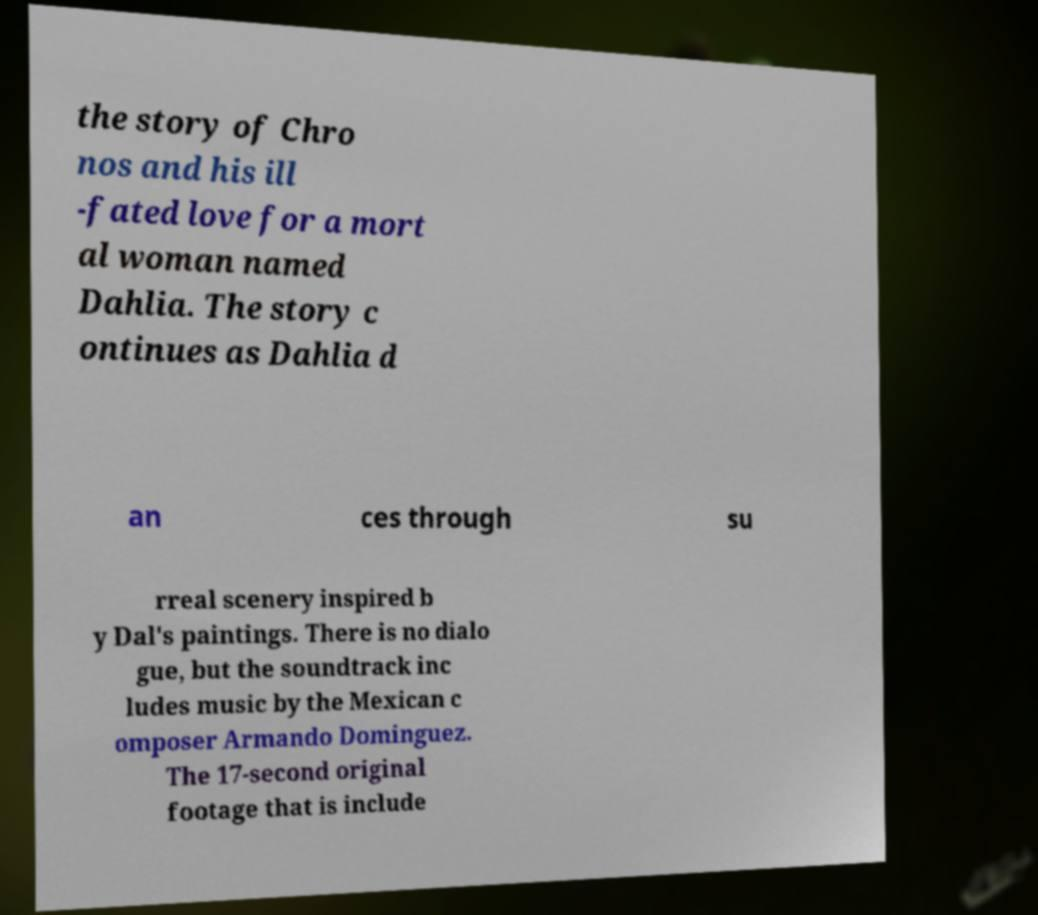Can you accurately transcribe the text from the provided image for me? the story of Chro nos and his ill -fated love for a mort al woman named Dahlia. The story c ontinues as Dahlia d an ces through su rreal scenery inspired b y Dal's paintings. There is no dialo gue, but the soundtrack inc ludes music by the Mexican c omposer Armando Dominguez. The 17-second original footage that is include 